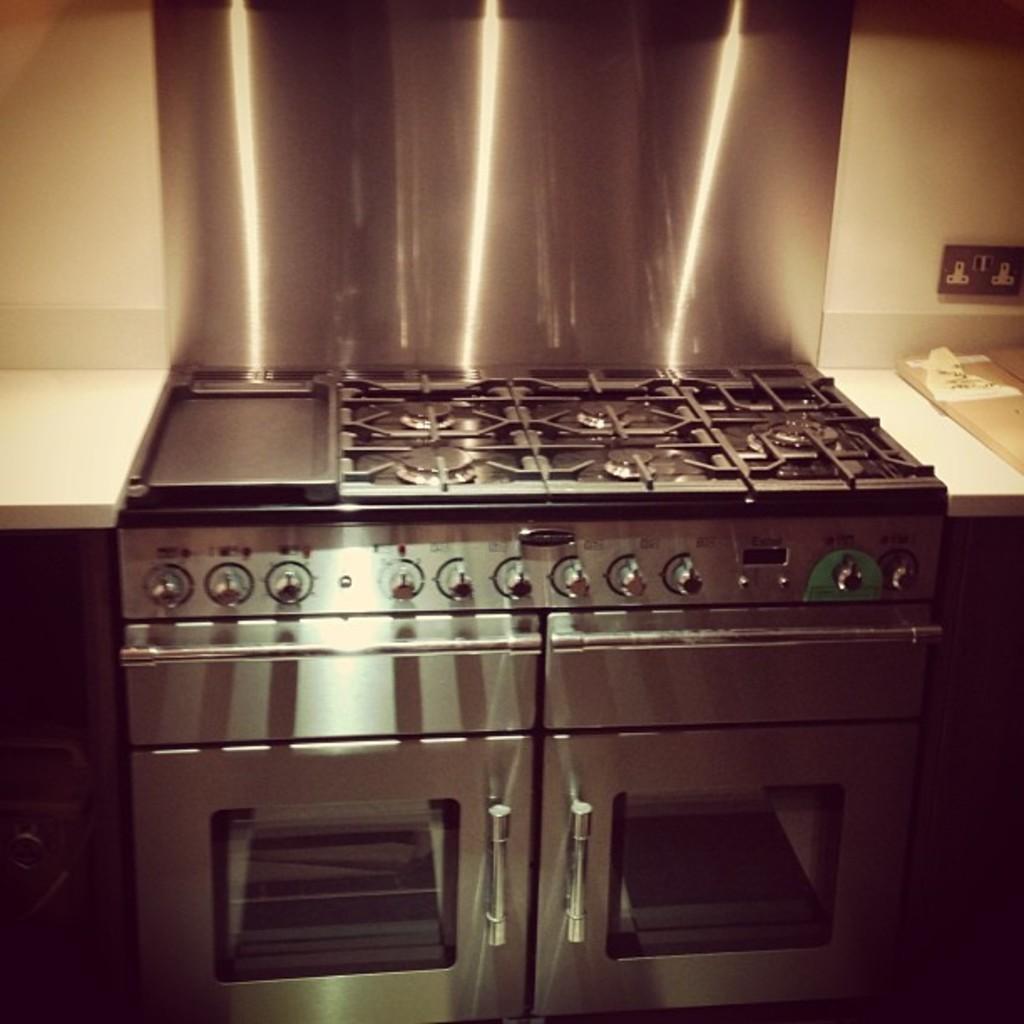Can you describe this image briefly? There is a stove on a kitchen countertop as we can see in the middle of this image , and there is a wall in the background. 